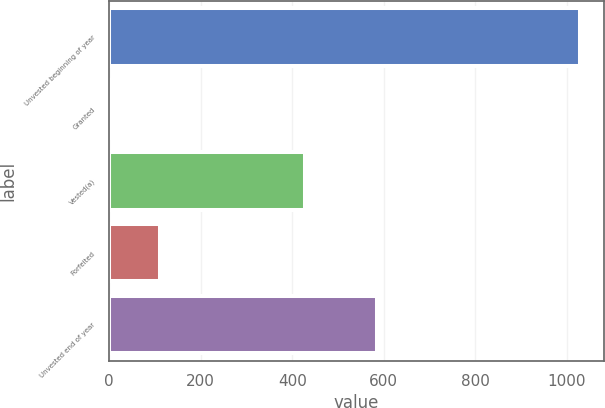<chart> <loc_0><loc_0><loc_500><loc_500><bar_chart><fcel>Unvested beginning of year<fcel>Granted<fcel>Vested(a)<fcel>Forfeited<fcel>Unvested end of year<nl><fcel>1030<fcel>8<fcel>428<fcel>110.2<fcel>586<nl></chart> 